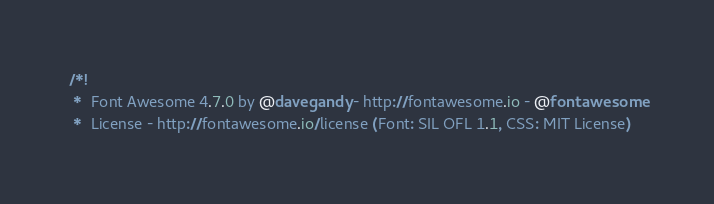Convert code to text. <code><loc_0><loc_0><loc_500><loc_500><_CSS_>/*!
 *  Font Awesome 4.7.0 by @davegandy - http://fontawesome.io - @fontawesome
 *  License - http://fontawesome.io/license (Font: SIL OFL 1.1, CSS: MIT License)</code> 